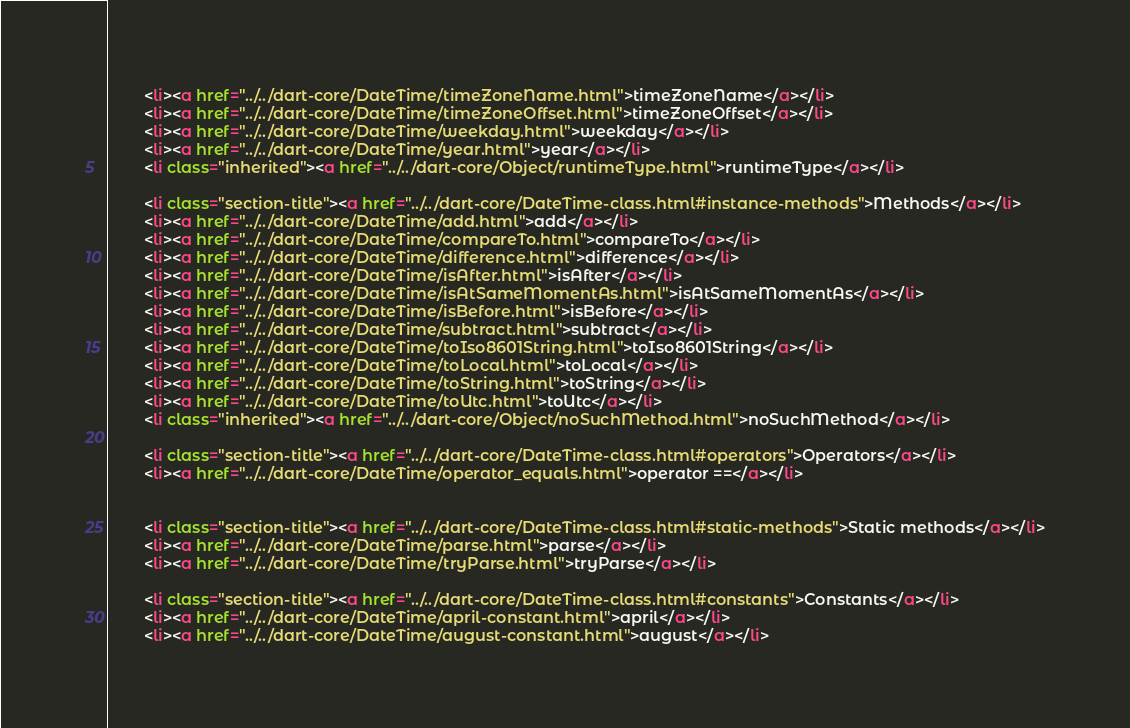Convert code to text. <code><loc_0><loc_0><loc_500><loc_500><_HTML_>        <li><a href="../../dart-core/DateTime/timeZoneName.html">timeZoneName</a></li>
        <li><a href="../../dart-core/DateTime/timeZoneOffset.html">timeZoneOffset</a></li>
        <li><a href="../../dart-core/DateTime/weekday.html">weekday</a></li>
        <li><a href="../../dart-core/DateTime/year.html">year</a></li>
        <li class="inherited"><a href="../../dart-core/Object/runtimeType.html">runtimeType</a></li>
    
        <li class="section-title"><a href="../../dart-core/DateTime-class.html#instance-methods">Methods</a></li>
        <li><a href="../../dart-core/DateTime/add.html">add</a></li>
        <li><a href="../../dart-core/DateTime/compareTo.html">compareTo</a></li>
        <li><a href="../../dart-core/DateTime/difference.html">difference</a></li>
        <li><a href="../../dart-core/DateTime/isAfter.html">isAfter</a></li>
        <li><a href="../../dart-core/DateTime/isAtSameMomentAs.html">isAtSameMomentAs</a></li>
        <li><a href="../../dart-core/DateTime/isBefore.html">isBefore</a></li>
        <li><a href="../../dart-core/DateTime/subtract.html">subtract</a></li>
        <li><a href="../../dart-core/DateTime/toIso8601String.html">toIso8601String</a></li>
        <li><a href="../../dart-core/DateTime/toLocal.html">toLocal</a></li>
        <li><a href="../../dart-core/DateTime/toString.html">toString</a></li>
        <li><a href="../../dart-core/DateTime/toUtc.html">toUtc</a></li>
        <li class="inherited"><a href="../../dart-core/Object/noSuchMethod.html">noSuchMethod</a></li>
    
        <li class="section-title"><a href="../../dart-core/DateTime-class.html#operators">Operators</a></li>
        <li><a href="../../dart-core/DateTime/operator_equals.html">operator ==</a></li>
    
    
        <li class="section-title"><a href="../../dart-core/DateTime-class.html#static-methods">Static methods</a></li>
        <li><a href="../../dart-core/DateTime/parse.html">parse</a></li>
        <li><a href="../../dart-core/DateTime/tryParse.html">tryParse</a></li>
    
        <li class="section-title"><a href="../../dart-core/DateTime-class.html#constants">Constants</a></li>
        <li><a href="../../dart-core/DateTime/april-constant.html">april</a></li>
        <li><a href="../../dart-core/DateTime/august-constant.html">august</a></li></code> 